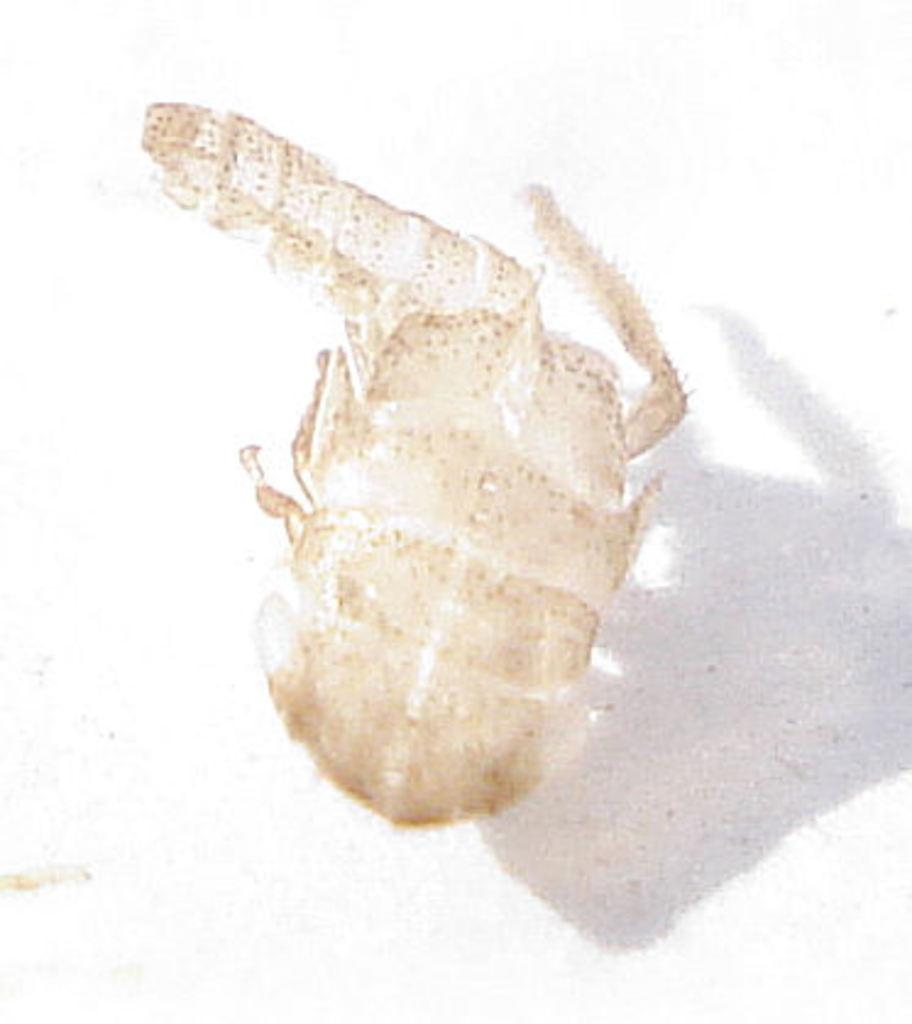What type of creature is present in the image? There is an insect in the image. How many houses can be seen in the image? There are no houses present in the image; it features an insect. What is the name of the partner who is downtown with the insect in the image? There is no partner or downtown location mentioned in the image, as it only features an insect. 